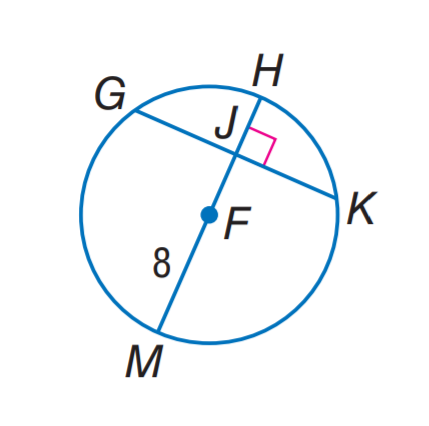Answer the mathemtical geometry problem and directly provide the correct option letter.
Question: In \odot F, G K = 14 and m \widehat G H K = 142. Find m \widehat G H.
Choices: A: 38 B: 71 C: 76 D: 142 B 